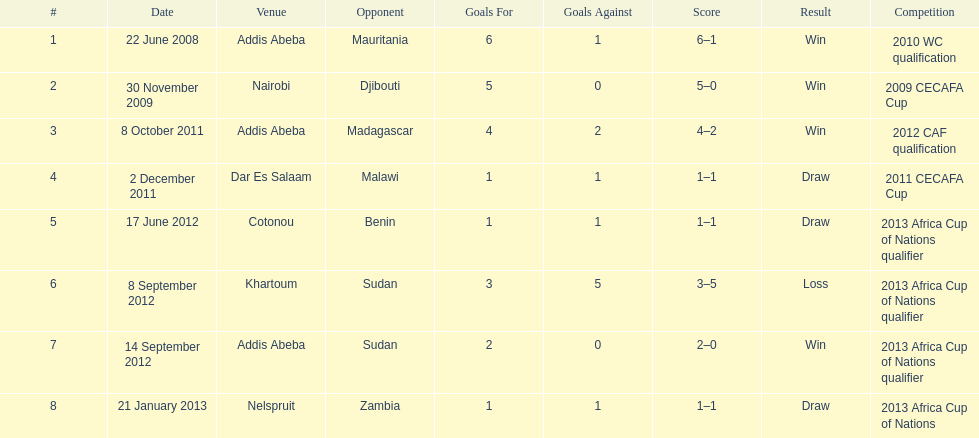What date gives was their only loss? 8 September 2012. 